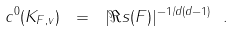<formula> <loc_0><loc_0><loc_500><loc_500>c ^ { 0 } ( K _ { F , v } ) \ = \ | \Re s ( F ) | ^ { - 1 / d ( d - 1 ) } \ .</formula> 